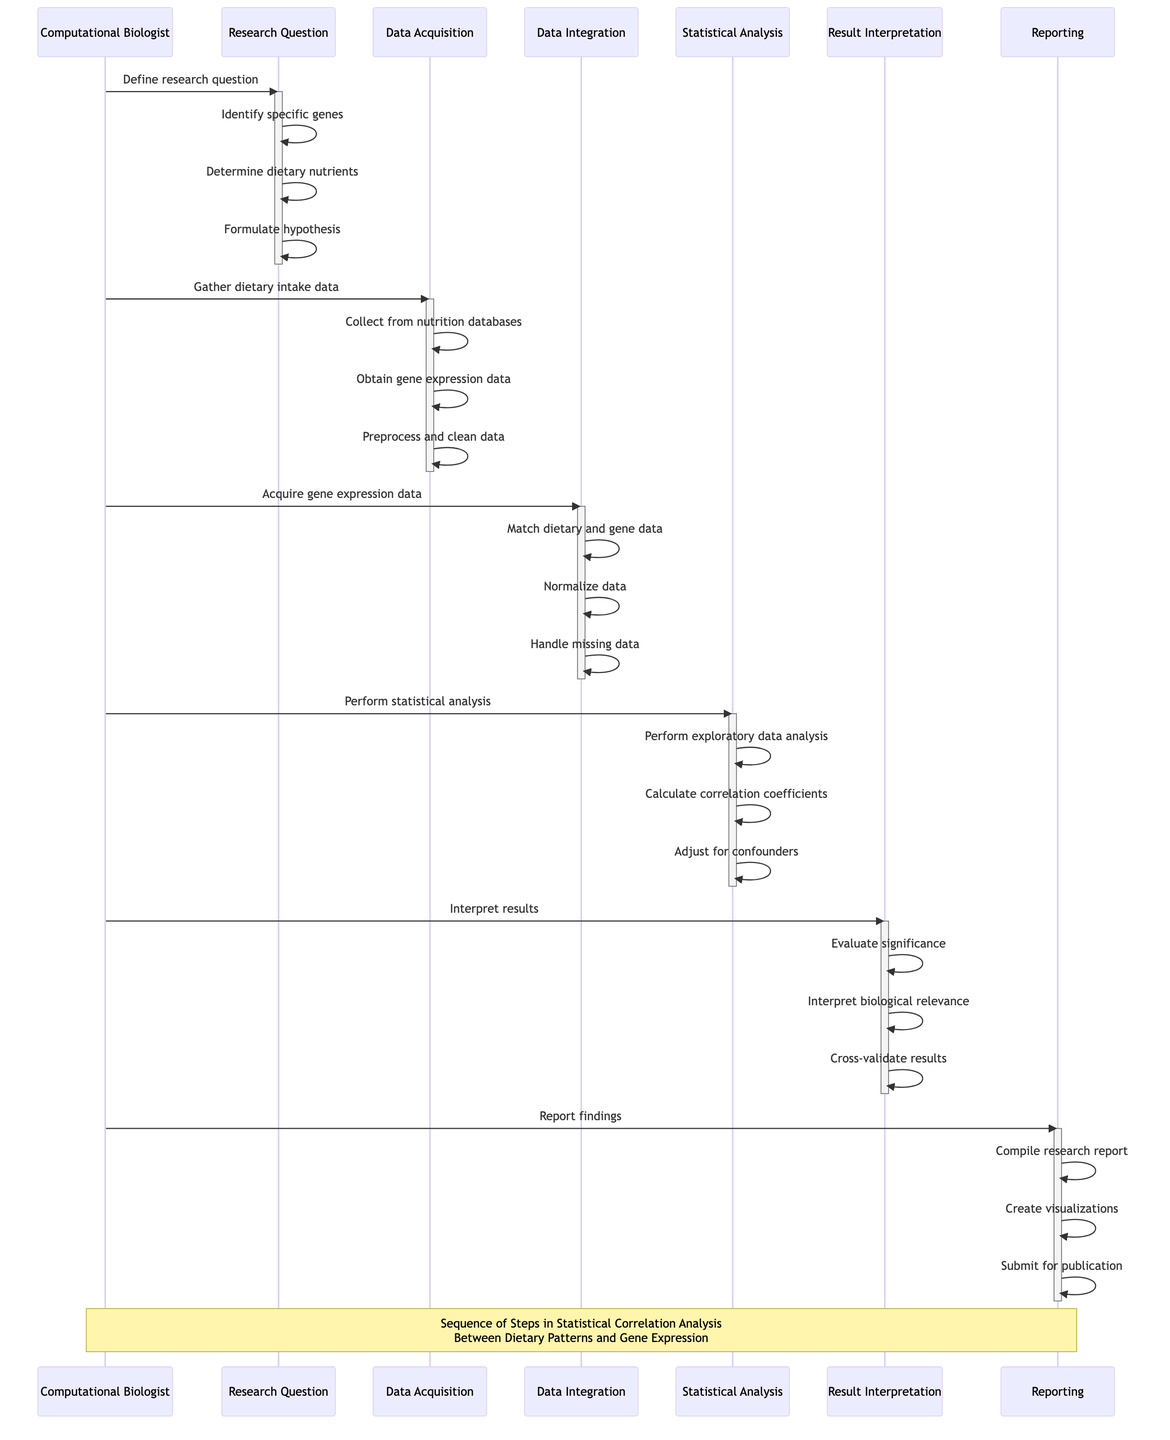What is the first step performed by the Computational Biologist? The first step is "Define research question" as shown in the diagram where the Computational Biologist first interacts with the Research Question object.
Answer: Define research question How many objects are involved in the sequence diagram? The diagram includes six objects: Research Question, Data Acquisition, Data Integration, Statistical Analysis, Result Interpretation, and Reporting. Counting these directly from the diagram gives the total number.
Answer: Six What does the Computational Biologist do after acquiring gene expression data? After acquiring gene expression data, the Computational Biologist performs "Data Integration," which involves steps such as matching dietary data with gene expression data.
Answer: Data Integration What step follows "Calculate correlation coefficients"? The next step after "Calculate correlation coefficients" is "Adjust for potential confounders" within the Statistical Analysis phase. This can be tracked through the linear flow in the diagram.
Answer: Adjust for potential confounders What is the last activity in the reporting process? The last activity in the reporting process is "Submit for publication," which is the final step taken after compiling findings and creating visualizations.
Answer: Submit for publication Which phase evaluates the significance of correlations? The phase that evaluates the significance of correlations is "Result Interpretation," as indicated in multiple interactions within that segment of the diagram.
Answer: Result Interpretation How many steps are in the Statistical Analysis phase? The Statistical Analysis phase consists of three steps: "Perform exploratory data analysis," "Calculate correlation coefficients," and "Adjust for potential confounders," as indicated in that section of the diagram.
Answer: Three What is the role of the Data Acquisition object? The role of the Data Acquisition object is to "Collect dietary intake data from nutrition databases," "Obtain gene expression data," and "Preprocess and clean data." This is functionally indicated in the steps under that object.
Answer: Collect dietary intake data Who is responsible for compiling findings into a research report? The responsibility for compiling findings into a research report lies with the Reporting object, which is explicitly indicated in the sequence as the first step in that section of the diagram.
Answer: Reporting 